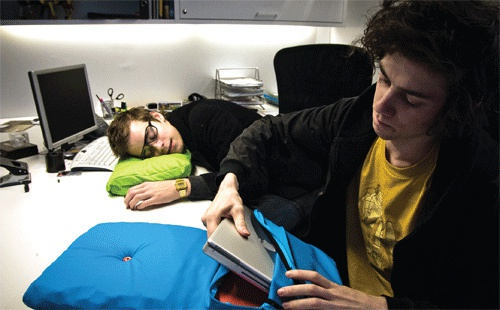Describe the objects in this image and their specific colors. I can see people in black, olive, maroon, and gray tones, backpack in black, gray, teal, and lightblue tones, people in black, olive, ivory, and tan tones, chair in black, gray, and darkgray tones, and tv in black, gray, and darkgray tones in this image. 